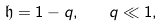Convert formula to latex. <formula><loc_0><loc_0><loc_500><loc_500>\mathfrak h = 1 - q , \quad q \ll 1 ,</formula> 